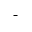<formula> <loc_0><loc_0><loc_500><loc_500>^ { - }</formula> 